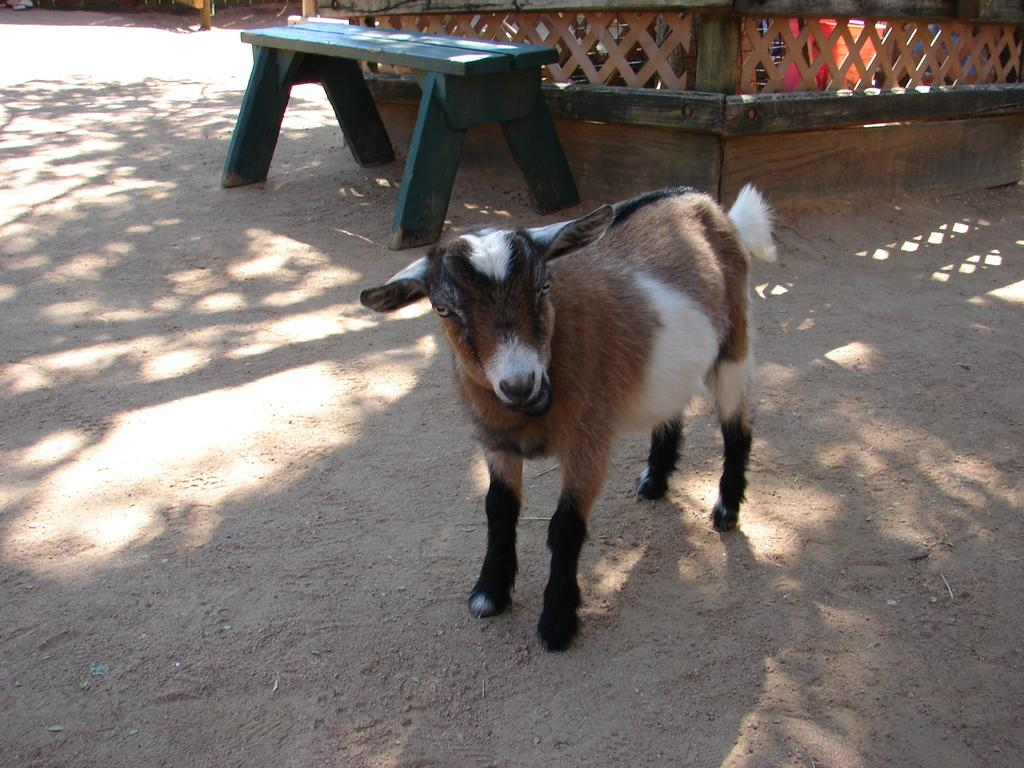What animal is present in the image? There is a goat in the image. What is the goat doing in the image? The goat is staring at something. What type of furniture can be seen in the background of the image? There is a bench in the background of the image. What type of structure is visible in the background of the image? There is a wooden house in the background of the image. What route does the monkey take to reach the goat in the image? There is no monkey present in the image, so there is no route to discuss. 